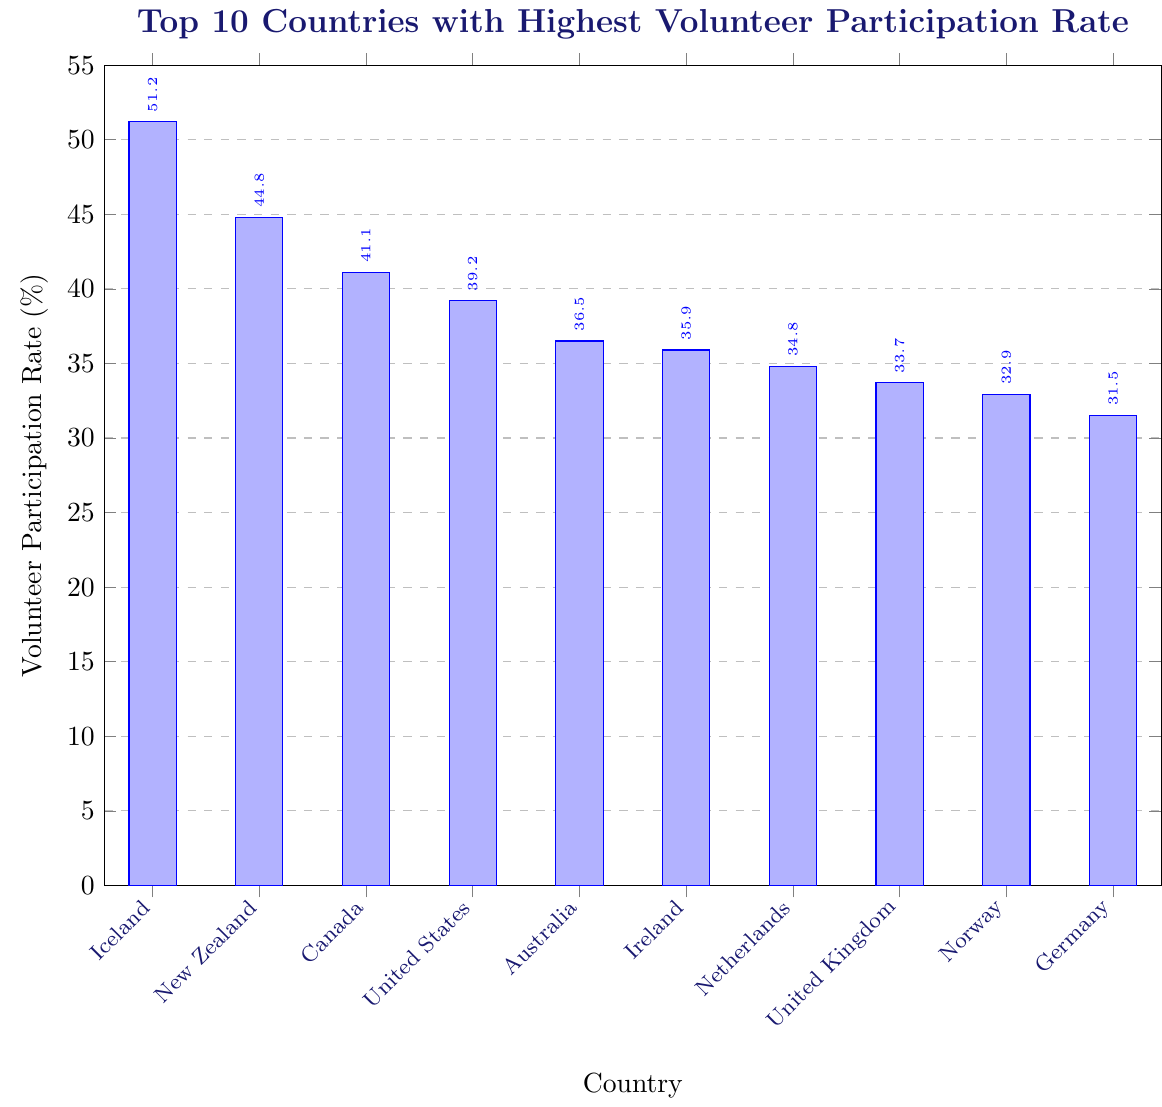What is the country with the highest volunteer participation rate? By looking at the highest bar on the chart, we can see that Iceland has the highest volunteer participation rate.
Answer: Iceland What is the percentage difference in volunteer participation rates between Iceland and New Zealand? Iceland has a volunteer participation rate of 51.2%, while New Zealand has 44.8%. The percentage difference is calculated as 51.2% - 44.8% = 6.4%.
Answer: 6.4% What is the average volunteer participation rate of the top 5 countries? The volunteer participation rates of the top 5 countries are Iceland (51.2%), New Zealand (44.8%), Canada (41.1%), United States (39.2%), and Australia (36.5%). The average is calculated as (51.2 + 44.8 + 41.1 + 39.2 + 36.5) / 5 = 42.56%.
Answer: 42.56% Are there any countries with almost the same volunteer participation rate? From the chart, we can see that the United Kingdom (33.7%) and Norway (32.9%) have similar volunteer participation rates, with only a difference of 0.8%.
Answer: Yes, United Kingdom and Norway Which country ranks 8th in terms of volunteer participation rate, and what is its rate? The chart shows that the 8th country is the United Kingdom with a volunteer participation rate of 33.7%.
Answer: United Kingdom, 33.7% How much higher is the volunteer participation rate in Canada compared to Germany? Canada has a volunteer participation rate of 41.1%, and Germany has 31.5%. The difference is calculated as 41.1% - 31.5% = 9.6%.
Answer: 9.6% Is the volunteer participation rate of Ireland higher than that of the Netherlands? By comparing the heights of the bars, we see that Ireland (35.9%) has a slightly higher volunteer participation rate than the Netherlands (34.8%).
Answer: Yes What is the combined volunteer participation rate for the top three countries? The volunteer participation rates for the top three countries are Iceland (51.2%), New Zealand (44.8%), and Canada (41.1%). The sum is 51.2% + 44.8% + 41.1% = 137.1%.
Answer: 137.1% What is the difference in volunteer participation rate between the country with the lowest rate (Germany) among the top 10 and the country with the highest rate (Iceland)? The volunteer participation rate for Iceland is 51.2%, and for Germany, it is 31.5%. The difference is calculated as 51.2% - 31.5% = 19.7%.
Answer: 19.7% 